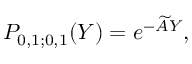<formula> <loc_0><loc_0><loc_500><loc_500>P _ { 0 , 1 ; 0 , 1 } ( Y ) = e ^ { - \widetilde { A } Y } ,</formula> 